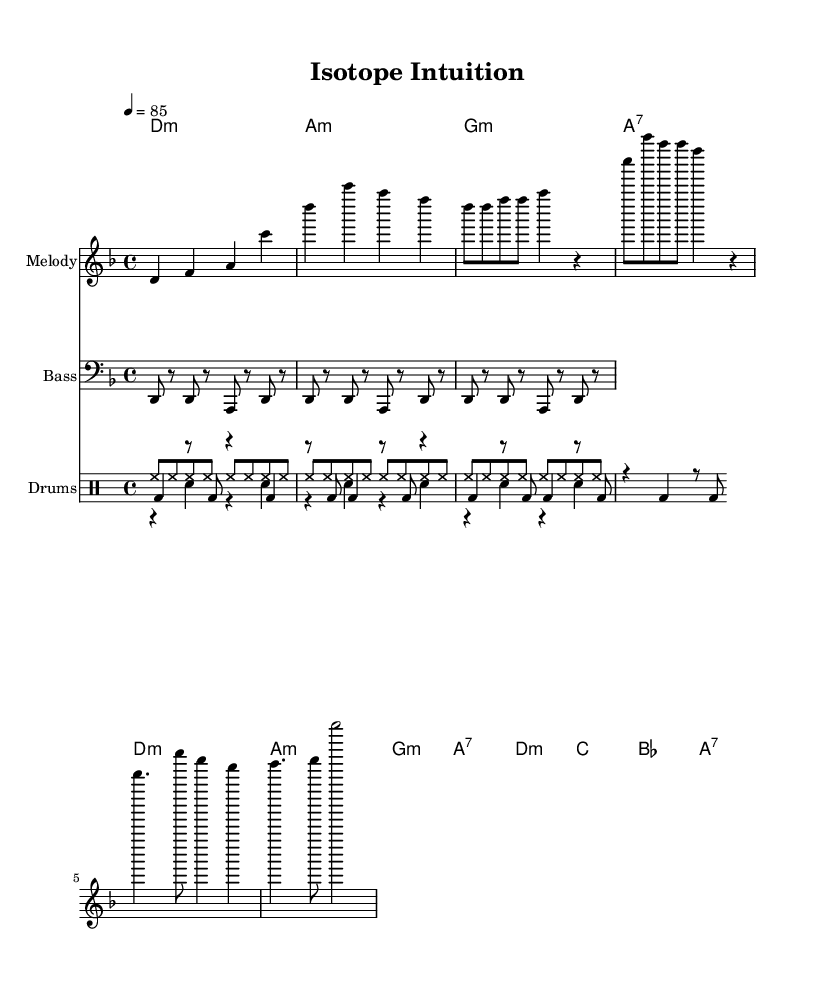What is the key signature of this music? The key signature is D minor, which has one flat (B flat). This can be identified by the key signature symbols at the beginning of the staff in the sheet music.
Answer: D minor What is the time signature of the piece? The time signature is 4/4, as indicated at the beginning of the score. This means there are four beats in a measure, and each quarter note gets one beat.
Answer: 4/4 What is the tempo marking for this music? The tempo marking is indicated as quarter note equals 85, meaning the piece should be played at a speed of 85 beats per minute. This helps performers understand the intended pace.
Answer: 85 What instruments are included in this score? The score includes a Melody, Bass, and Drums, evidenced by the instrument names specified at the beginning of each staff in the sheet music.
Answer: Melody, Bass, Drums What chord follows the first measure of the chorus? The first measure of the chorus features the D minor chord, as indicated in the chord names section of the score that corresponds with the melody.
Answer: D minor How many times is the drum kick pattern repeated? The drum kick pattern is repeated three times, as denoted by the marking 'repeat unfold 3' in the drum section of the score.
Answer: 3 